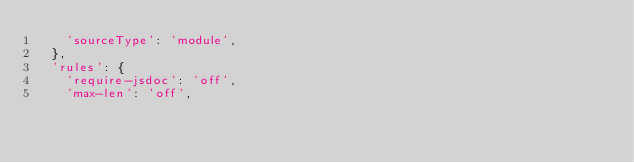Convert code to text. <code><loc_0><loc_0><loc_500><loc_500><_JavaScript_>    'sourceType': 'module',
  },
  'rules': {
    'require-jsdoc': 'off',
    'max-len': 'off',</code> 